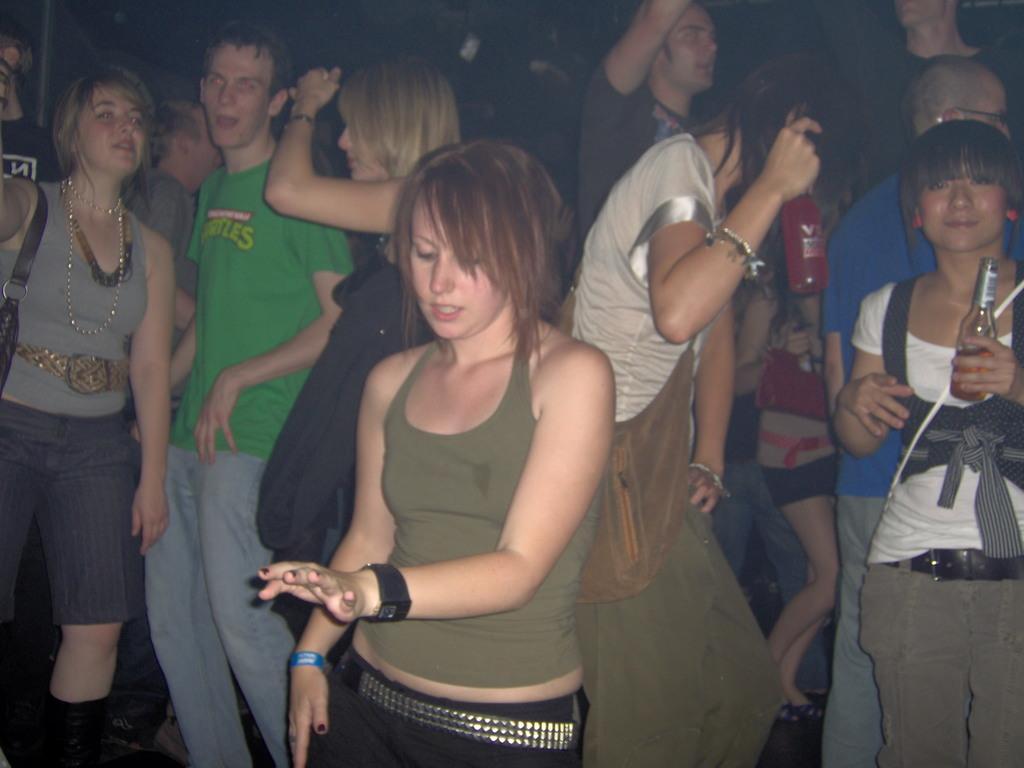Could you give a brief overview of what you see in this image? In the center of the image we can see a few people are standing and they are in different costumes. Among them, we can see a few people are holding bottles and one person is smiling. In the background, we can see it is blurred. 